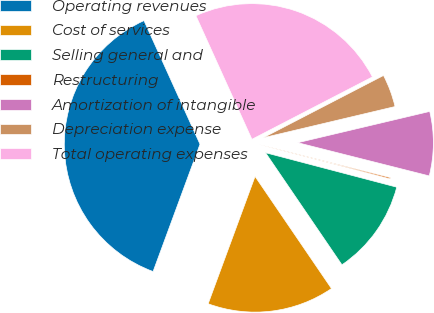Convert chart to OTSL. <chart><loc_0><loc_0><loc_500><loc_500><pie_chart><fcel>Operating revenues<fcel>Cost of services<fcel>Selling general and<fcel>Restructuring<fcel>Amortization of intangible<fcel>Depreciation expense<fcel>Total operating expenses<nl><fcel>37.61%<fcel>15.14%<fcel>11.39%<fcel>0.15%<fcel>7.64%<fcel>3.9%<fcel>24.17%<nl></chart> 